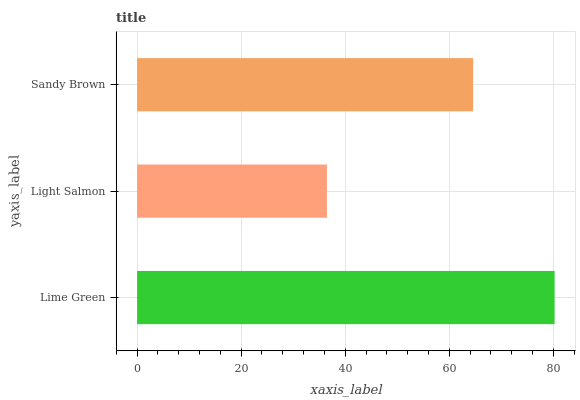Is Light Salmon the minimum?
Answer yes or no. Yes. Is Lime Green the maximum?
Answer yes or no. Yes. Is Sandy Brown the minimum?
Answer yes or no. No. Is Sandy Brown the maximum?
Answer yes or no. No. Is Sandy Brown greater than Light Salmon?
Answer yes or no. Yes. Is Light Salmon less than Sandy Brown?
Answer yes or no. Yes. Is Light Salmon greater than Sandy Brown?
Answer yes or no. No. Is Sandy Brown less than Light Salmon?
Answer yes or no. No. Is Sandy Brown the high median?
Answer yes or no. Yes. Is Sandy Brown the low median?
Answer yes or no. Yes. Is Lime Green the high median?
Answer yes or no. No. Is Light Salmon the low median?
Answer yes or no. No. 